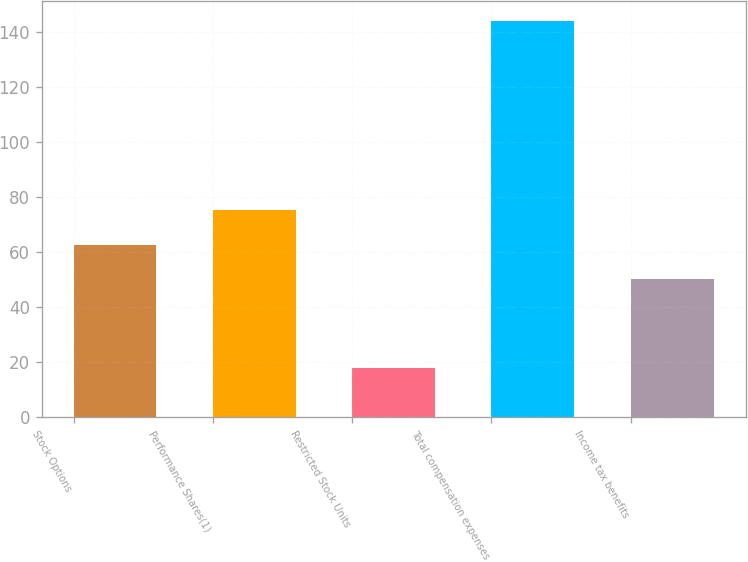Convert chart. <chart><loc_0><loc_0><loc_500><loc_500><bar_chart><fcel>Stock Options<fcel>Performance Shares(1)<fcel>Restricted Stock Units<fcel>Total compensation expenses<fcel>Income tax benefits<nl><fcel>62.6<fcel>75.2<fcel>18<fcel>144<fcel>50<nl></chart> 